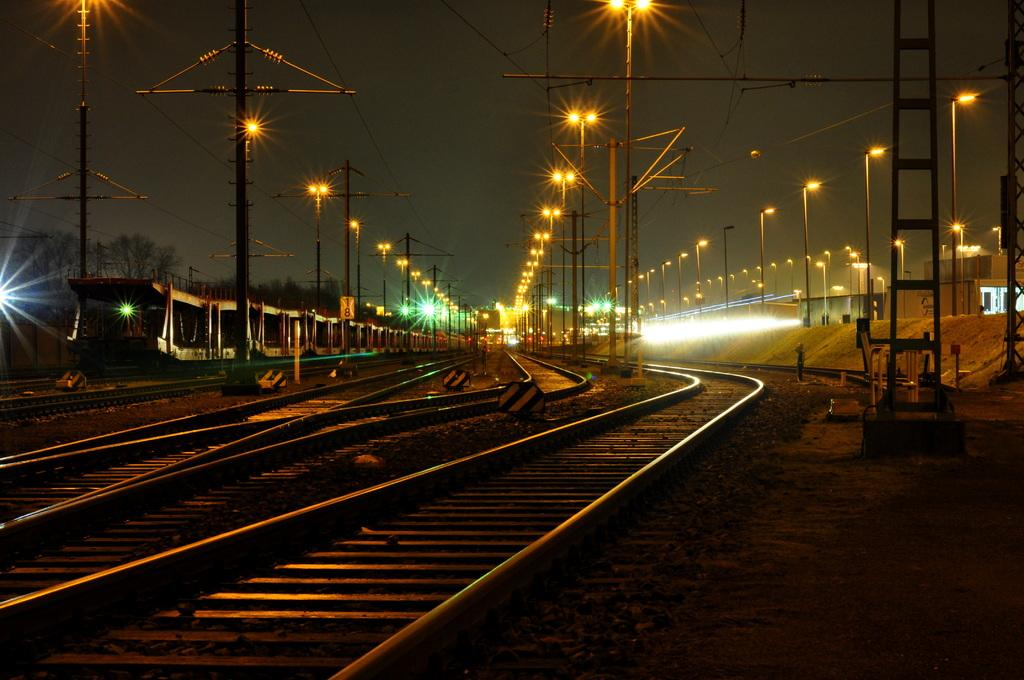What type of transportation infrastructure is visible in the image? There are railway tracks in the image. What other structures can be seen in the image? There is a fence wall in the image. Where is the train located in the image? The train is in the left corner of the image. What type of lighting is present in the background of the image? There are street lights in the background of the image. What type of instrument is being played by the side of the railway tracks in the image? There is no instrument being played in the image; it only features railway tracks, a fence wall, a train, and street lights. 